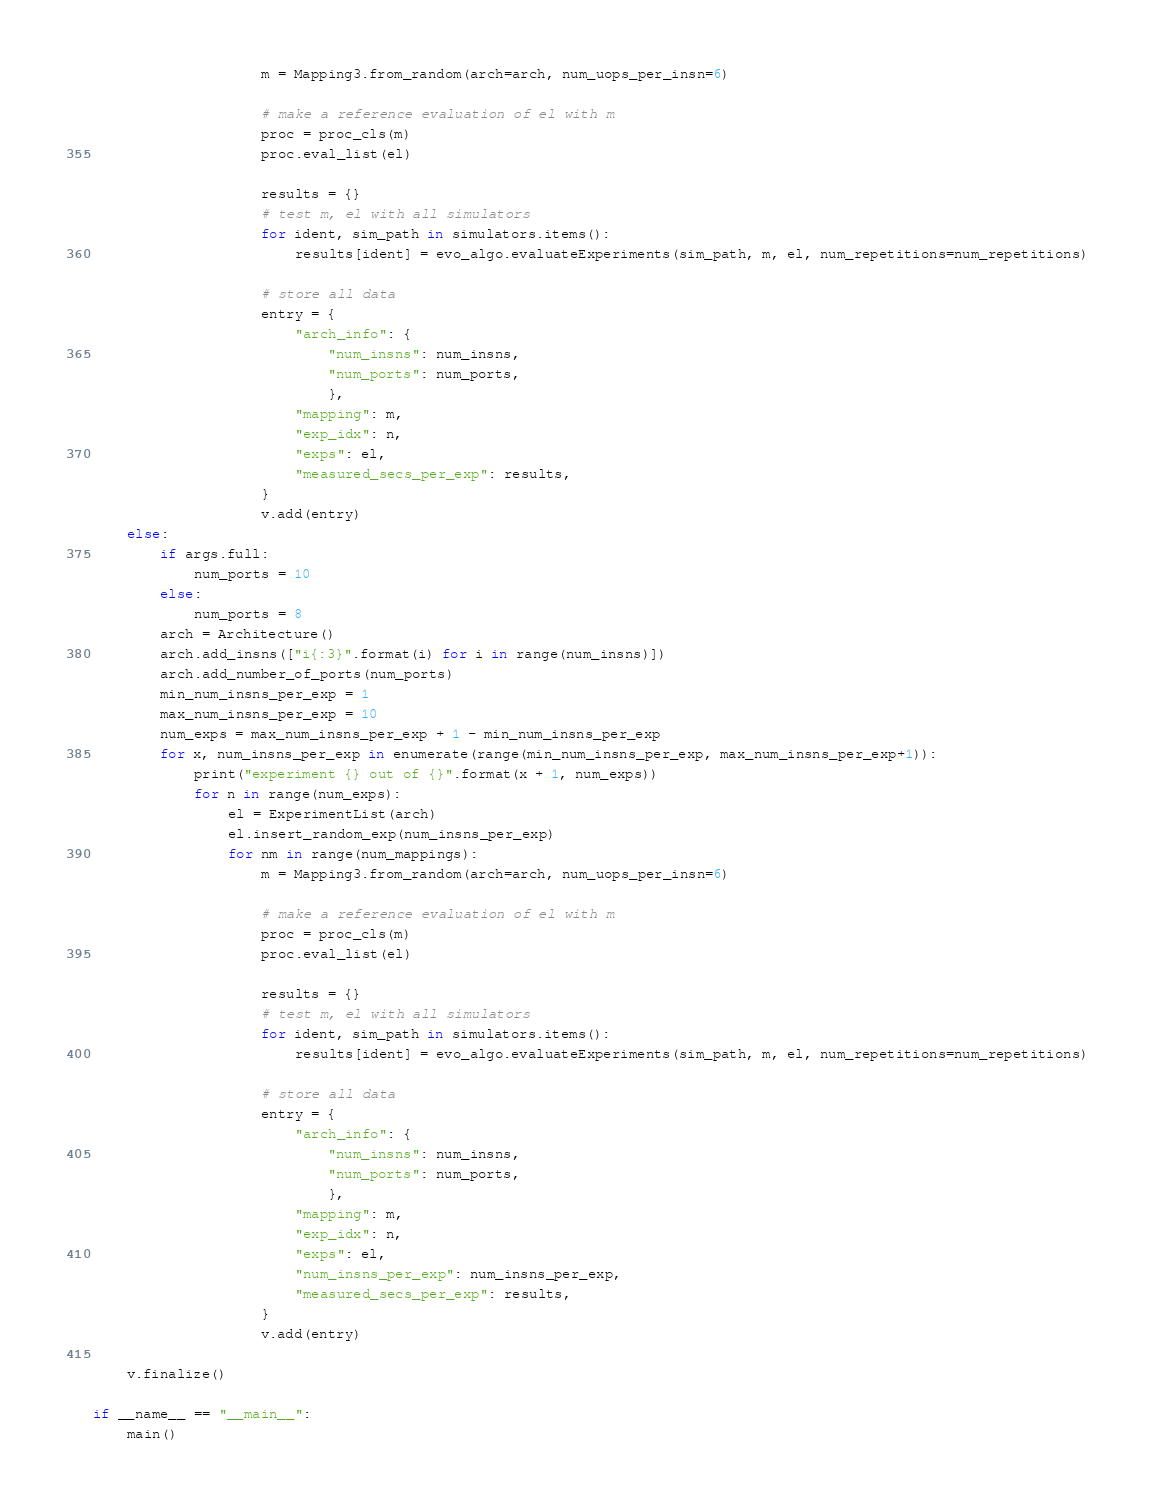Convert code to text. <code><loc_0><loc_0><loc_500><loc_500><_Python_>                    m = Mapping3.from_random(arch=arch, num_uops_per_insn=6)

                    # make a reference evaluation of el with m
                    proc = proc_cls(m)
                    proc.eval_list(el)

                    results = {}
                    # test m, el with all simulators
                    for ident, sim_path in simulators.items():
                        results[ident] = evo_algo.evaluateExperiments(sim_path, m, el, num_repetitions=num_repetitions)

                    # store all data
                    entry = {
                        "arch_info": {
                            "num_insns": num_insns,
                            "num_ports": num_ports,
                            },
                        "mapping": m,
                        "exp_idx": n,
                        "exps": el,
                        "measured_secs_per_exp": results,
                    }
                    v.add(entry)
    else:
        if args.full:
            num_ports = 10
        else:
            num_ports = 8
        arch = Architecture()
        arch.add_insns(["i{:3}".format(i) for i in range(num_insns)])
        arch.add_number_of_ports(num_ports)
        min_num_insns_per_exp = 1
        max_num_insns_per_exp = 10
        num_exps = max_num_insns_per_exp + 1 - min_num_insns_per_exp
        for x, num_insns_per_exp in enumerate(range(min_num_insns_per_exp, max_num_insns_per_exp+1)):
            print("experiment {} out of {}".format(x + 1, num_exps))
            for n in range(num_exps):
                el = ExperimentList(arch)
                el.insert_random_exp(num_insns_per_exp)
                for nm in range(num_mappings):
                    m = Mapping3.from_random(arch=arch, num_uops_per_insn=6)

                    # make a reference evaluation of el with m
                    proc = proc_cls(m)
                    proc.eval_list(el)

                    results = {}
                    # test m, el with all simulators
                    for ident, sim_path in simulators.items():
                        results[ident] = evo_algo.evaluateExperiments(sim_path, m, el, num_repetitions=num_repetitions)

                    # store all data
                    entry = {
                        "arch_info": {
                            "num_insns": num_insns,
                            "num_ports": num_ports,
                            },
                        "mapping": m,
                        "exp_idx": n,
                        "exps": el,
                        "num_insns_per_exp": num_insns_per_exp,
                        "measured_secs_per_exp": results,
                    }
                    v.add(entry)

    v.finalize()

if __name__ == "__main__":
    main()
</code> 